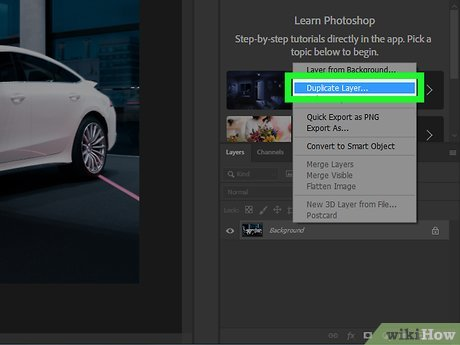Explain how duplicating a layer in Photoshop can be beneficial in editing images. Duplicating a layer in Photoshop is highly beneficial as it allows you to make non-destructive edits. This means you can alter, enhance, or apply effects to the duplicate layer without affecting the original image data. It's ideal for experimenting with different adjustments or corrections while keeping the underlying original layer intact for safety. 